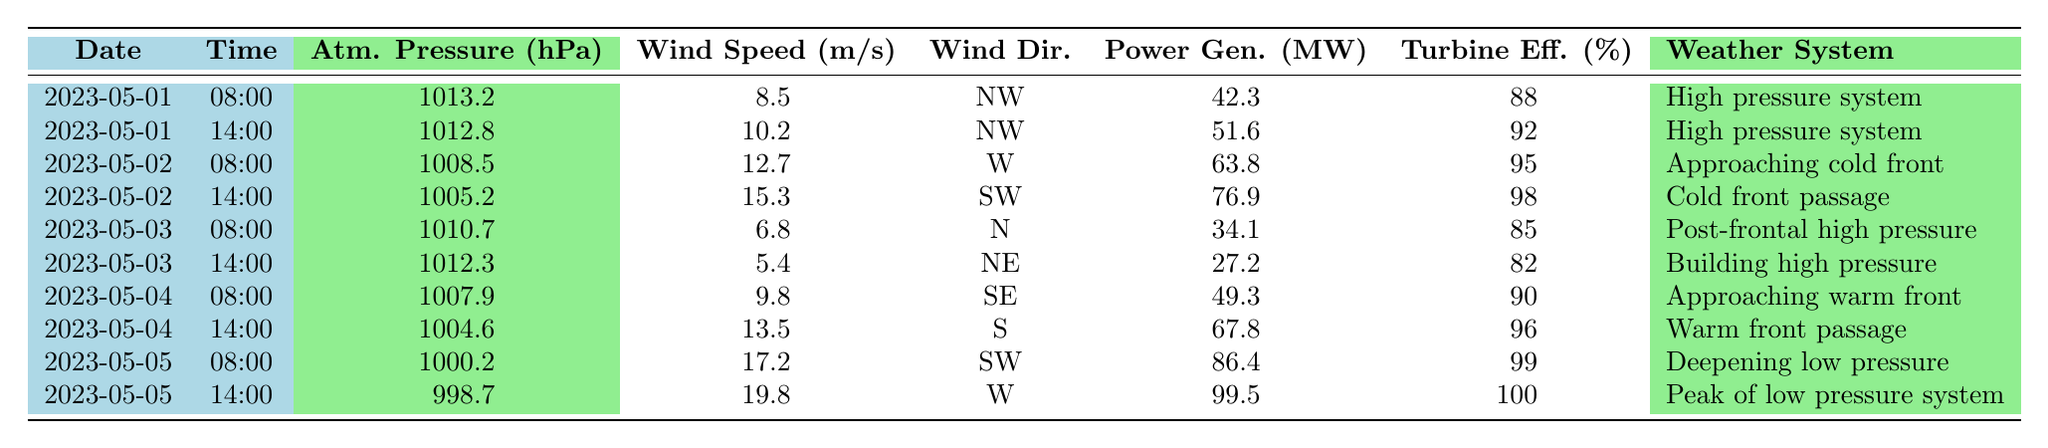What was the atmospheric pressure on May 2 at 14:00? The table shows that on May 2 at 14:00, the atmospheric pressure recorded was 1005.2 hPa.
Answer: 1005.2 hPa What was the maximum power generation recorded in the table? The maximum power generation in the table is found on May 5 at 14:00, which is 99.5 MW.
Answer: 99.5 MW What is the average wind speed recorded on May 1? The wind speeds on May 1 are 8.5 m/s and 10.2 m/s. The average is (8.5 + 10.2) / 2 = 9.35 m/s.
Answer: 9.35 m/s Was there any time that the turbine efficiency dropped below 85%? The turbine efficiencies listed range from 82% to 100%, showing that at least one instance (on May 3, 14:00) dropped below 85%.
Answer: Yes How does atmospheric pressure change from May 1 to May 5? On May 1, the pressure was 1013.2 hPa, and on May 5, it dropped to 998.7 hPa. The difference is 1013.2 - 998.7 = 14.5 hPa, indicating a decrease.
Answer: Decrease of 14.5 hPa What was the average turbine efficiency over the entire period? The turbine efficiencies are 88, 92, 95, 98, 85, 82, 90, 96, 99, and 100. Summing these values gives 925, and there are 10 entries, so the average is 925 / 10 = 92.5%.
Answer: 92.5% Which weather system corresponded with the highest wind speed? The highest wind speed was 19.8 m/s on May 5 at 14:00, corresponding with the "Peak of low pressure system."
Answer: Peak of low pressure system How does the power generation on May 4 compare with that on May 3? The power generation on May 4 is 49.3 MW and 67.8 MW, while on May 3, it is 34.1 MW and 27.2 MW. The total for May 4 is 49.3 + 67.8 = 117.1 MW, and for May 3, it is 34.1 + 27.2 = 61.3 MW, indicating more power was generated on May 4.
Answer: More power was generated on May 4 Was there a day where both wind speed and power generation decreased compared to the previous day? Yes, on May 3 compared to May 2, wind speed decreased from 15.3 m/s to 5.4 m/s and power generation decreased from 76.9 MW to 27.2 MW.
Answer: Yes What was the trend in atmospheric pressure throughout the recorded days? The atmospheric pressure decreased from 1013.2 hPa to 1005.2 hPa on May 2, then to 1010.7 hPa on May 3, again decreased to 1004.6 hPa on May 4, and finally to 998.7 hPa on May 5, indicating a general decline with fluctuations.
Answer: General decline with fluctuations 